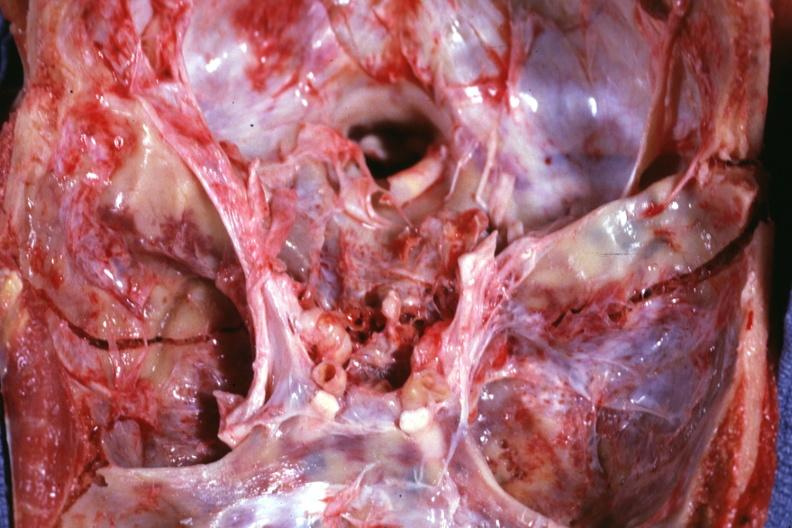s basilar skull fracture present?
Answer the question using a single word or phrase. Yes 